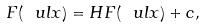Convert formula to latex. <formula><loc_0><loc_0><loc_500><loc_500>F ( \ u l x ) = H F ( \ u l x ) + c ,</formula> 